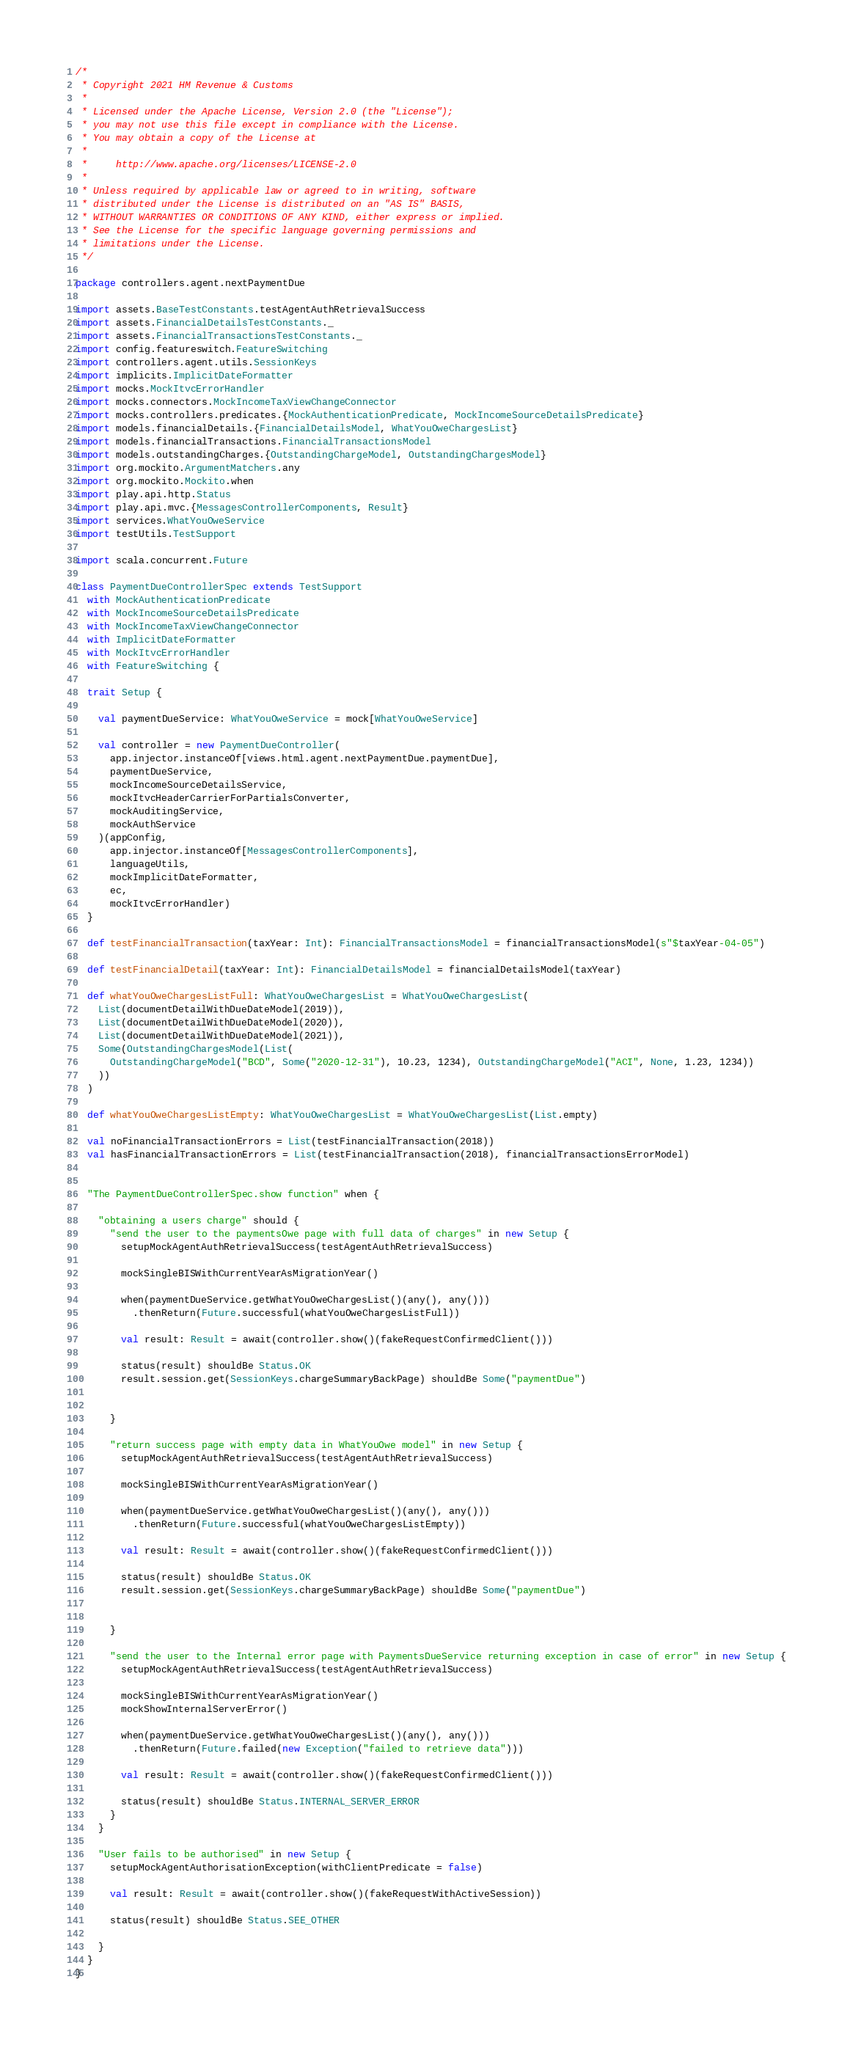<code> <loc_0><loc_0><loc_500><loc_500><_Scala_>/*
 * Copyright 2021 HM Revenue & Customs
 *
 * Licensed under the Apache License, Version 2.0 (the "License");
 * you may not use this file except in compliance with the License.
 * You may obtain a copy of the License at
 *
 *     http://www.apache.org/licenses/LICENSE-2.0
 *
 * Unless required by applicable law or agreed to in writing, software
 * distributed under the License is distributed on an "AS IS" BASIS,
 * WITHOUT WARRANTIES OR CONDITIONS OF ANY KIND, either express or implied.
 * See the License for the specific language governing permissions and
 * limitations under the License.
 */

package controllers.agent.nextPaymentDue

import assets.BaseTestConstants.testAgentAuthRetrievalSuccess
import assets.FinancialDetailsTestConstants._
import assets.FinancialTransactionsTestConstants._
import config.featureswitch.FeatureSwitching
import controllers.agent.utils.SessionKeys
import implicits.ImplicitDateFormatter
import mocks.MockItvcErrorHandler
import mocks.connectors.MockIncomeTaxViewChangeConnector
import mocks.controllers.predicates.{MockAuthenticationPredicate, MockIncomeSourceDetailsPredicate}
import models.financialDetails.{FinancialDetailsModel, WhatYouOweChargesList}
import models.financialTransactions.FinancialTransactionsModel
import models.outstandingCharges.{OutstandingChargeModel, OutstandingChargesModel}
import org.mockito.ArgumentMatchers.any
import org.mockito.Mockito.when
import play.api.http.Status
import play.api.mvc.{MessagesControllerComponents, Result}
import services.WhatYouOweService
import testUtils.TestSupport

import scala.concurrent.Future

class PaymentDueControllerSpec extends TestSupport
  with MockAuthenticationPredicate
  with MockIncomeSourceDetailsPredicate
  with MockIncomeTaxViewChangeConnector
  with ImplicitDateFormatter
  with MockItvcErrorHandler
  with FeatureSwitching {

  trait Setup {

    val paymentDueService: WhatYouOweService = mock[WhatYouOweService]

    val controller = new PaymentDueController(
      app.injector.instanceOf[views.html.agent.nextPaymentDue.paymentDue],
      paymentDueService,
      mockIncomeSourceDetailsService,
      mockItvcHeaderCarrierForPartialsConverter,
      mockAuditingService,
      mockAuthService
    )(appConfig,
      app.injector.instanceOf[MessagesControllerComponents],
      languageUtils,
      mockImplicitDateFormatter,
      ec,
      mockItvcErrorHandler)
  }

  def testFinancialTransaction(taxYear: Int): FinancialTransactionsModel = financialTransactionsModel(s"$taxYear-04-05")

  def testFinancialDetail(taxYear: Int): FinancialDetailsModel = financialDetailsModel(taxYear)

  def whatYouOweChargesListFull: WhatYouOweChargesList = WhatYouOweChargesList(
    List(documentDetailWithDueDateModel(2019)),
    List(documentDetailWithDueDateModel(2020)),
    List(documentDetailWithDueDateModel(2021)),
    Some(OutstandingChargesModel(List(
      OutstandingChargeModel("BCD", Some("2020-12-31"), 10.23, 1234), OutstandingChargeModel("ACI", None, 1.23, 1234))
    ))
  )

  def whatYouOweChargesListEmpty: WhatYouOweChargesList = WhatYouOweChargesList(List.empty)

  val noFinancialTransactionErrors = List(testFinancialTransaction(2018))
  val hasFinancialTransactionErrors = List(testFinancialTransaction(2018), financialTransactionsErrorModel)


  "The PaymentDueControllerSpec.show function" when {

    "obtaining a users charge" should {
      "send the user to the paymentsOwe page with full data of charges" in new Setup {
        setupMockAgentAuthRetrievalSuccess(testAgentAuthRetrievalSuccess)

        mockSingleBISWithCurrentYearAsMigrationYear()

        when(paymentDueService.getWhatYouOweChargesList()(any(), any()))
          .thenReturn(Future.successful(whatYouOweChargesListFull))

        val result: Result = await(controller.show()(fakeRequestConfirmedClient()))

        status(result) shouldBe Status.OK
        result.session.get(SessionKeys.chargeSummaryBackPage) shouldBe Some("paymentDue")


      }

      "return success page with empty data in WhatYouOwe model" in new Setup {
        setupMockAgentAuthRetrievalSuccess(testAgentAuthRetrievalSuccess)

        mockSingleBISWithCurrentYearAsMigrationYear()

        when(paymentDueService.getWhatYouOweChargesList()(any(), any()))
          .thenReturn(Future.successful(whatYouOweChargesListEmpty))

        val result: Result = await(controller.show()(fakeRequestConfirmedClient()))

        status(result) shouldBe Status.OK
        result.session.get(SessionKeys.chargeSummaryBackPage) shouldBe Some("paymentDue")


      }

      "send the user to the Internal error page with PaymentsDueService returning exception in case of error" in new Setup {
        setupMockAgentAuthRetrievalSuccess(testAgentAuthRetrievalSuccess)

        mockSingleBISWithCurrentYearAsMigrationYear()
        mockShowInternalServerError()

        when(paymentDueService.getWhatYouOweChargesList()(any(), any()))
          .thenReturn(Future.failed(new Exception("failed to retrieve data")))

        val result: Result = await(controller.show()(fakeRequestConfirmedClient()))

        status(result) shouldBe Status.INTERNAL_SERVER_ERROR
      }
    }

    "User fails to be authorised" in new Setup {
      setupMockAgentAuthorisationException(withClientPredicate = false)

      val result: Result = await(controller.show()(fakeRequestWithActiveSession))

      status(result) shouldBe Status.SEE_OTHER

    }
  }
}
</code> 